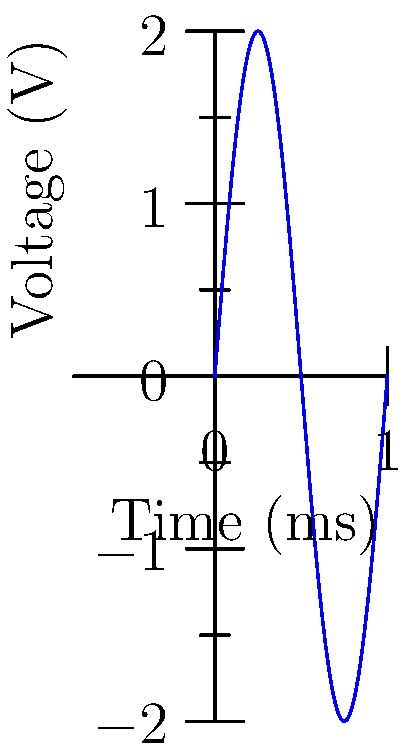As an aspiring writer seeking to understand the rhythm and pattern in storytelling, you stumble upon an oscilloscope display in a science museum. The waveform shown represents a sinusoidal voltage signal. If each horizontal division represents 0.25 ms, what is the frequency of this signal in kHz? To find the frequency of the signal, we need to follow these steps:

1. Identify the period (T) of the waveform:
   - One complete cycle of the sine wave spans 4 horizontal divisions
   - Each division represents 0.25 ms
   - So, T = 4 * 0.25 ms = 1 ms

2. Calculate the frequency (f) using the formula:
   $$ f = \frac{1}{T} $$

3. Convert the units:
   $$ f = \frac{1}{1 \text{ ms}} = 1000 \text{ Hz} = 1 \text{ kHz} $$

Just as a writer crafts a story with a consistent rhythm, this waveform repeats its pattern at a regular interval, creating a frequency of 1 kHz.
Answer: 1 kHz 